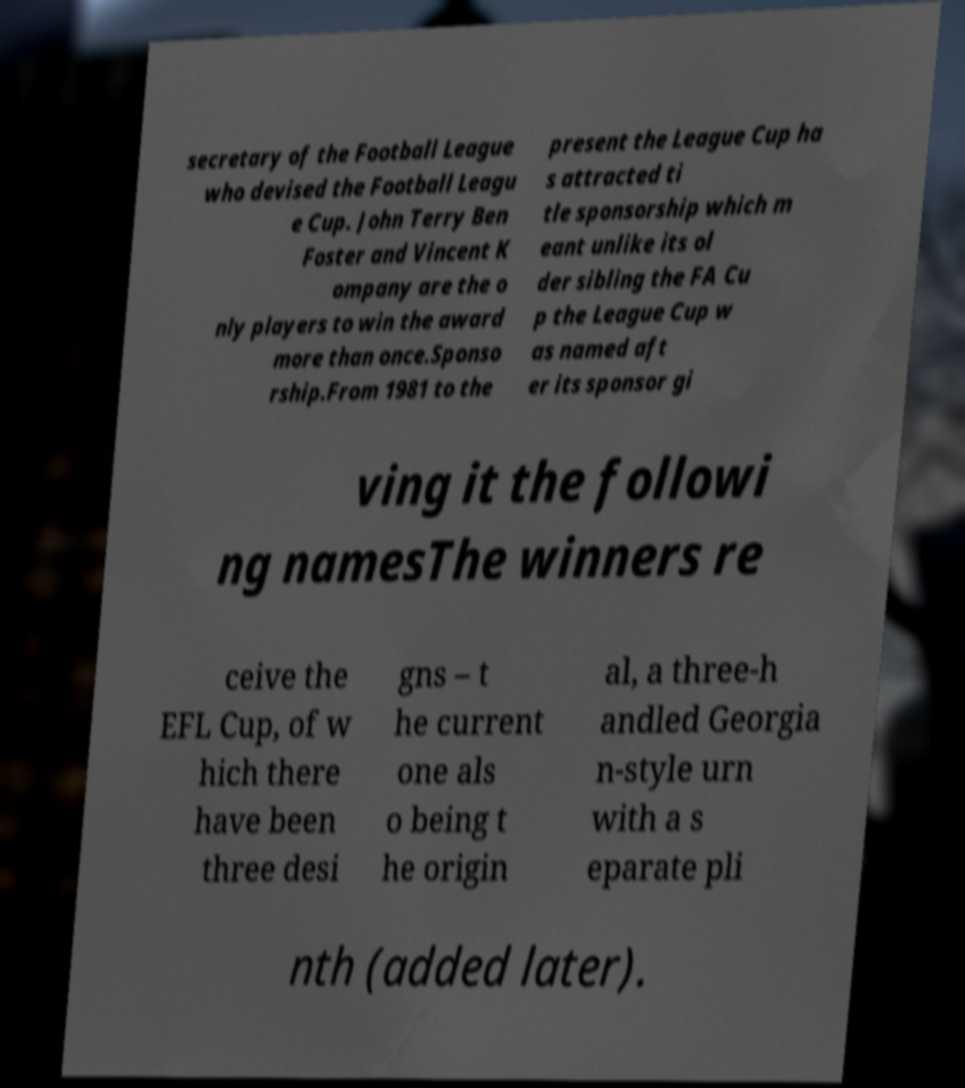I need the written content from this picture converted into text. Can you do that? secretary of the Football League who devised the Football Leagu e Cup. John Terry Ben Foster and Vincent K ompany are the o nly players to win the award more than once.Sponso rship.From 1981 to the present the League Cup ha s attracted ti tle sponsorship which m eant unlike its ol der sibling the FA Cu p the League Cup w as named aft er its sponsor gi ving it the followi ng namesThe winners re ceive the EFL Cup, of w hich there have been three desi gns – t he current one als o being t he origin al, a three-h andled Georgia n-style urn with a s eparate pli nth (added later). 